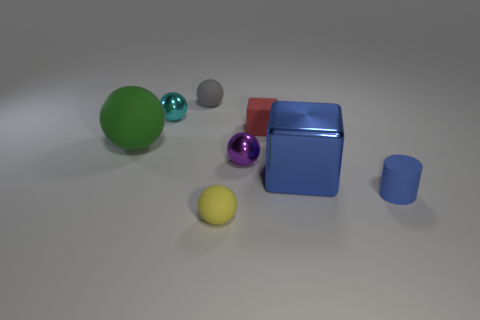How many objects are things behind the blue cube or big green objects?
Provide a short and direct response. 5. The cyan thing that is made of the same material as the large blue cube is what shape?
Ensure brevity in your answer.  Sphere. Is there any other thing that is the same shape as the tiny purple shiny object?
Make the answer very short. Yes. The rubber thing that is on the right side of the big green rubber thing and to the left of the tiny yellow sphere is what color?
Provide a succinct answer. Gray. What number of cylinders are yellow matte things or small blue things?
Offer a very short reply. 1. How many matte balls are the same size as the cyan thing?
Your response must be concise. 2. There is a block behind the big blue shiny thing; what number of small red matte blocks are on the right side of it?
Your response must be concise. 0. How big is the rubber ball that is to the right of the green object and behind the small purple metallic ball?
Make the answer very short. Small. Is the number of gray objects greater than the number of objects?
Ensure brevity in your answer.  No. Are there any tiny balls of the same color as the matte cylinder?
Make the answer very short. No. 